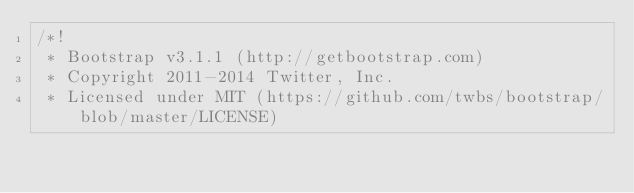Convert code to text. <code><loc_0><loc_0><loc_500><loc_500><_CSS_>/*!
 * Bootstrap v3.1.1 (http://getbootstrap.com)
 * Copyright 2011-2014 Twitter, Inc.
 * Licensed under MIT (https://github.com/twbs/bootstrap/blob/master/LICENSE)</code> 